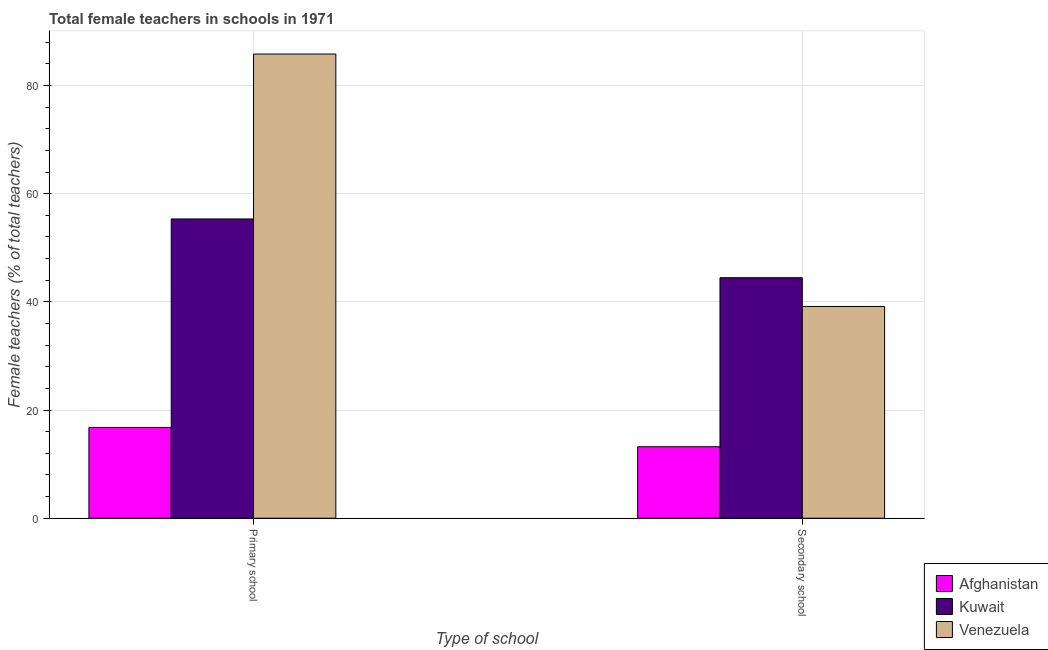How many groups of bars are there?
Provide a succinct answer. 2. What is the label of the 2nd group of bars from the left?
Ensure brevity in your answer.  Secondary school. What is the percentage of female teachers in primary schools in Afghanistan?
Give a very brief answer. 16.78. Across all countries, what is the maximum percentage of female teachers in secondary schools?
Offer a very short reply. 44.47. Across all countries, what is the minimum percentage of female teachers in secondary schools?
Offer a very short reply. 13.22. In which country was the percentage of female teachers in secondary schools maximum?
Your answer should be very brief. Kuwait. In which country was the percentage of female teachers in secondary schools minimum?
Make the answer very short. Afghanistan. What is the total percentage of female teachers in secondary schools in the graph?
Provide a succinct answer. 96.84. What is the difference between the percentage of female teachers in secondary schools in Kuwait and that in Afghanistan?
Ensure brevity in your answer.  31.25. What is the difference between the percentage of female teachers in secondary schools in Afghanistan and the percentage of female teachers in primary schools in Venezuela?
Make the answer very short. -72.6. What is the average percentage of female teachers in secondary schools per country?
Provide a short and direct response. 32.28. What is the difference between the percentage of female teachers in secondary schools and percentage of female teachers in primary schools in Afghanistan?
Make the answer very short. -3.56. In how many countries, is the percentage of female teachers in primary schools greater than 68 %?
Give a very brief answer. 1. What is the ratio of the percentage of female teachers in primary schools in Kuwait to that in Venezuela?
Your answer should be compact. 0.64. Is the percentage of female teachers in primary schools in Kuwait less than that in Afghanistan?
Ensure brevity in your answer.  No. In how many countries, is the percentage of female teachers in primary schools greater than the average percentage of female teachers in primary schools taken over all countries?
Your answer should be very brief. 2. What does the 2nd bar from the left in Primary school represents?
Ensure brevity in your answer.  Kuwait. What does the 2nd bar from the right in Secondary school represents?
Make the answer very short. Kuwait. Are all the bars in the graph horizontal?
Provide a short and direct response. No. What is the difference between two consecutive major ticks on the Y-axis?
Provide a short and direct response. 20. Does the graph contain any zero values?
Provide a succinct answer. No. Does the graph contain grids?
Offer a very short reply. Yes. How many legend labels are there?
Your response must be concise. 3. How are the legend labels stacked?
Give a very brief answer. Vertical. What is the title of the graph?
Your response must be concise. Total female teachers in schools in 1971. What is the label or title of the X-axis?
Ensure brevity in your answer.  Type of school. What is the label or title of the Y-axis?
Offer a terse response. Female teachers (% of total teachers). What is the Female teachers (% of total teachers) in Afghanistan in Primary school?
Keep it short and to the point. 16.78. What is the Female teachers (% of total teachers) in Kuwait in Primary school?
Your response must be concise. 55.33. What is the Female teachers (% of total teachers) of Venezuela in Primary school?
Your response must be concise. 85.82. What is the Female teachers (% of total teachers) in Afghanistan in Secondary school?
Your response must be concise. 13.22. What is the Female teachers (% of total teachers) of Kuwait in Secondary school?
Provide a short and direct response. 44.47. What is the Female teachers (% of total teachers) of Venezuela in Secondary school?
Offer a terse response. 39.15. Across all Type of school, what is the maximum Female teachers (% of total teachers) in Afghanistan?
Provide a short and direct response. 16.78. Across all Type of school, what is the maximum Female teachers (% of total teachers) of Kuwait?
Make the answer very short. 55.33. Across all Type of school, what is the maximum Female teachers (% of total teachers) in Venezuela?
Your answer should be very brief. 85.82. Across all Type of school, what is the minimum Female teachers (% of total teachers) in Afghanistan?
Provide a short and direct response. 13.22. Across all Type of school, what is the minimum Female teachers (% of total teachers) in Kuwait?
Keep it short and to the point. 44.47. Across all Type of school, what is the minimum Female teachers (% of total teachers) of Venezuela?
Provide a short and direct response. 39.15. What is the total Female teachers (% of total teachers) of Afghanistan in the graph?
Your response must be concise. 30. What is the total Female teachers (% of total teachers) of Kuwait in the graph?
Ensure brevity in your answer.  99.8. What is the total Female teachers (% of total teachers) of Venezuela in the graph?
Provide a short and direct response. 124.97. What is the difference between the Female teachers (% of total teachers) of Afghanistan in Primary school and that in Secondary school?
Ensure brevity in your answer.  3.56. What is the difference between the Female teachers (% of total teachers) in Kuwait in Primary school and that in Secondary school?
Ensure brevity in your answer.  10.86. What is the difference between the Female teachers (% of total teachers) of Venezuela in Primary school and that in Secondary school?
Give a very brief answer. 46.67. What is the difference between the Female teachers (% of total teachers) of Afghanistan in Primary school and the Female teachers (% of total teachers) of Kuwait in Secondary school?
Your response must be concise. -27.68. What is the difference between the Female teachers (% of total teachers) in Afghanistan in Primary school and the Female teachers (% of total teachers) in Venezuela in Secondary school?
Offer a terse response. -22.37. What is the difference between the Female teachers (% of total teachers) of Kuwait in Primary school and the Female teachers (% of total teachers) of Venezuela in Secondary school?
Ensure brevity in your answer.  16.18. What is the average Female teachers (% of total teachers) of Afghanistan per Type of school?
Provide a short and direct response. 15. What is the average Female teachers (% of total teachers) of Kuwait per Type of school?
Your response must be concise. 49.9. What is the average Female teachers (% of total teachers) in Venezuela per Type of school?
Ensure brevity in your answer.  62.49. What is the difference between the Female teachers (% of total teachers) in Afghanistan and Female teachers (% of total teachers) in Kuwait in Primary school?
Give a very brief answer. -38.55. What is the difference between the Female teachers (% of total teachers) in Afghanistan and Female teachers (% of total teachers) in Venezuela in Primary school?
Your answer should be very brief. -69.04. What is the difference between the Female teachers (% of total teachers) in Kuwait and Female teachers (% of total teachers) in Venezuela in Primary school?
Your response must be concise. -30.49. What is the difference between the Female teachers (% of total teachers) in Afghanistan and Female teachers (% of total teachers) in Kuwait in Secondary school?
Provide a short and direct response. -31.25. What is the difference between the Female teachers (% of total teachers) of Afghanistan and Female teachers (% of total teachers) of Venezuela in Secondary school?
Ensure brevity in your answer.  -25.93. What is the difference between the Female teachers (% of total teachers) in Kuwait and Female teachers (% of total teachers) in Venezuela in Secondary school?
Offer a very short reply. 5.32. What is the ratio of the Female teachers (% of total teachers) in Afghanistan in Primary school to that in Secondary school?
Provide a succinct answer. 1.27. What is the ratio of the Female teachers (% of total teachers) in Kuwait in Primary school to that in Secondary school?
Provide a succinct answer. 1.24. What is the ratio of the Female teachers (% of total teachers) of Venezuela in Primary school to that in Secondary school?
Offer a very short reply. 2.19. What is the difference between the highest and the second highest Female teachers (% of total teachers) in Afghanistan?
Your answer should be very brief. 3.56. What is the difference between the highest and the second highest Female teachers (% of total teachers) of Kuwait?
Your response must be concise. 10.86. What is the difference between the highest and the second highest Female teachers (% of total teachers) of Venezuela?
Give a very brief answer. 46.67. What is the difference between the highest and the lowest Female teachers (% of total teachers) in Afghanistan?
Make the answer very short. 3.56. What is the difference between the highest and the lowest Female teachers (% of total teachers) in Kuwait?
Give a very brief answer. 10.86. What is the difference between the highest and the lowest Female teachers (% of total teachers) of Venezuela?
Your answer should be very brief. 46.67. 